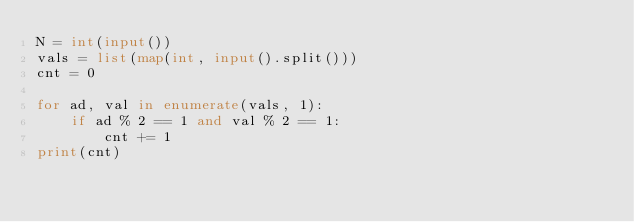Convert code to text. <code><loc_0><loc_0><loc_500><loc_500><_Python_>N = int(input())
vals = list(map(int, input().split()))
cnt = 0

for ad, val in enumerate(vals, 1):
    if ad % 2 == 1 and val % 2 == 1:
        cnt += 1
print(cnt) </code> 